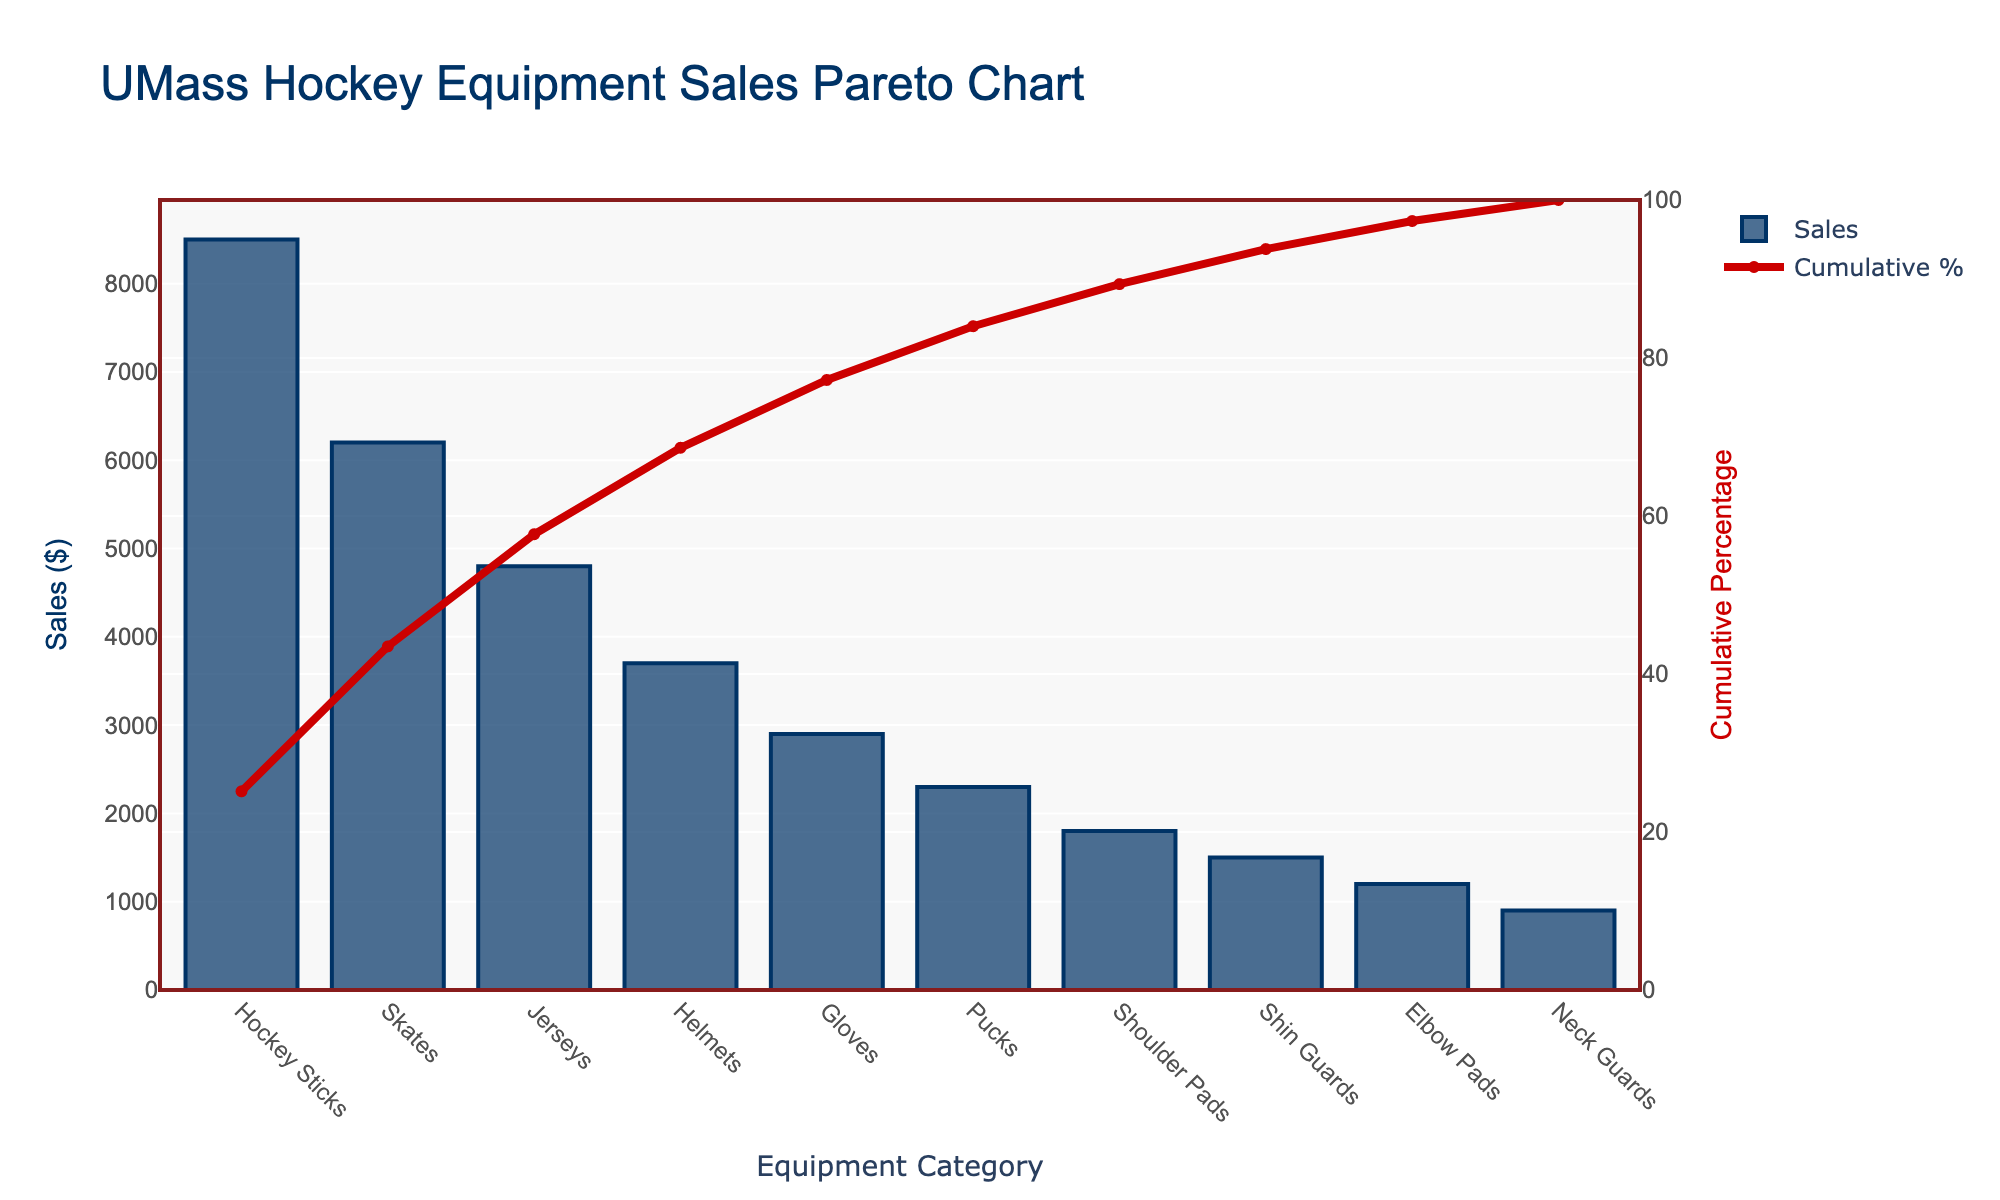What is the title of the chart? The title of the chart is usually located at the top of the figure.
Answer: UMass Hockey Equipment Sales Pareto Chart Which equipment category has the highest sales? Look for the category with the tallest bar.
Answer: Hockey Sticks What is the cumulative percentage after skates? Find the point on the cumulative percentage line that corresponds to the end of the 'Skates' bar.
Answer: 55.5% How much more in sales do hockey sticks have compared to gloves? Identify the sales values for hockey sticks and gloves, then subtract the sales of gloves from that of hockey sticks (8500 - 2900).
Answer: 5600 What is the total sales for helmets and jerseys combined? Add the sales values for helmets and jerseys (3700 + 4800).
Answer: 8500 Which categories account for the top 80% of cumulative sales? Scan the cumulative percentage line to find where it crosses 80%, then list the categories up to that point.
Answer: Hockey Sticks, Skates, Jerseys, Helmets, Gloves How do the sales of jerseys compare to the sales of shin guards? Compare the heights of the bars for jerseys and shin guards or check their values (4800 vs. 1500).
Answer: Jerseys sales are higher What is the cumulative percentage represented by the elbow pads category alone? Locate the cumulative percentage value at the top of the elbow pads bar.
Answer: 97.6% What is the difference in sales between pucks and shoulder pads? Subtract the sales of shoulder pads from the sales of pucks (2300 - 1800).
Answer: 500 Which categories are contributing the least in terms of cumulative percentage? Identify the categories with the smallest bars and cumulative percentages.
Answer: Neck Guards, Elbow Pads 